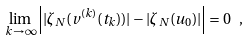<formula> <loc_0><loc_0><loc_500><loc_500>\lim _ { k \to \infty } \left | | \zeta _ { N } ( v ^ { ( k ) } ( t _ { k } ) ) | - | \zeta _ { N } ( u _ { 0 } ) | \right | = 0 \ ,</formula> 